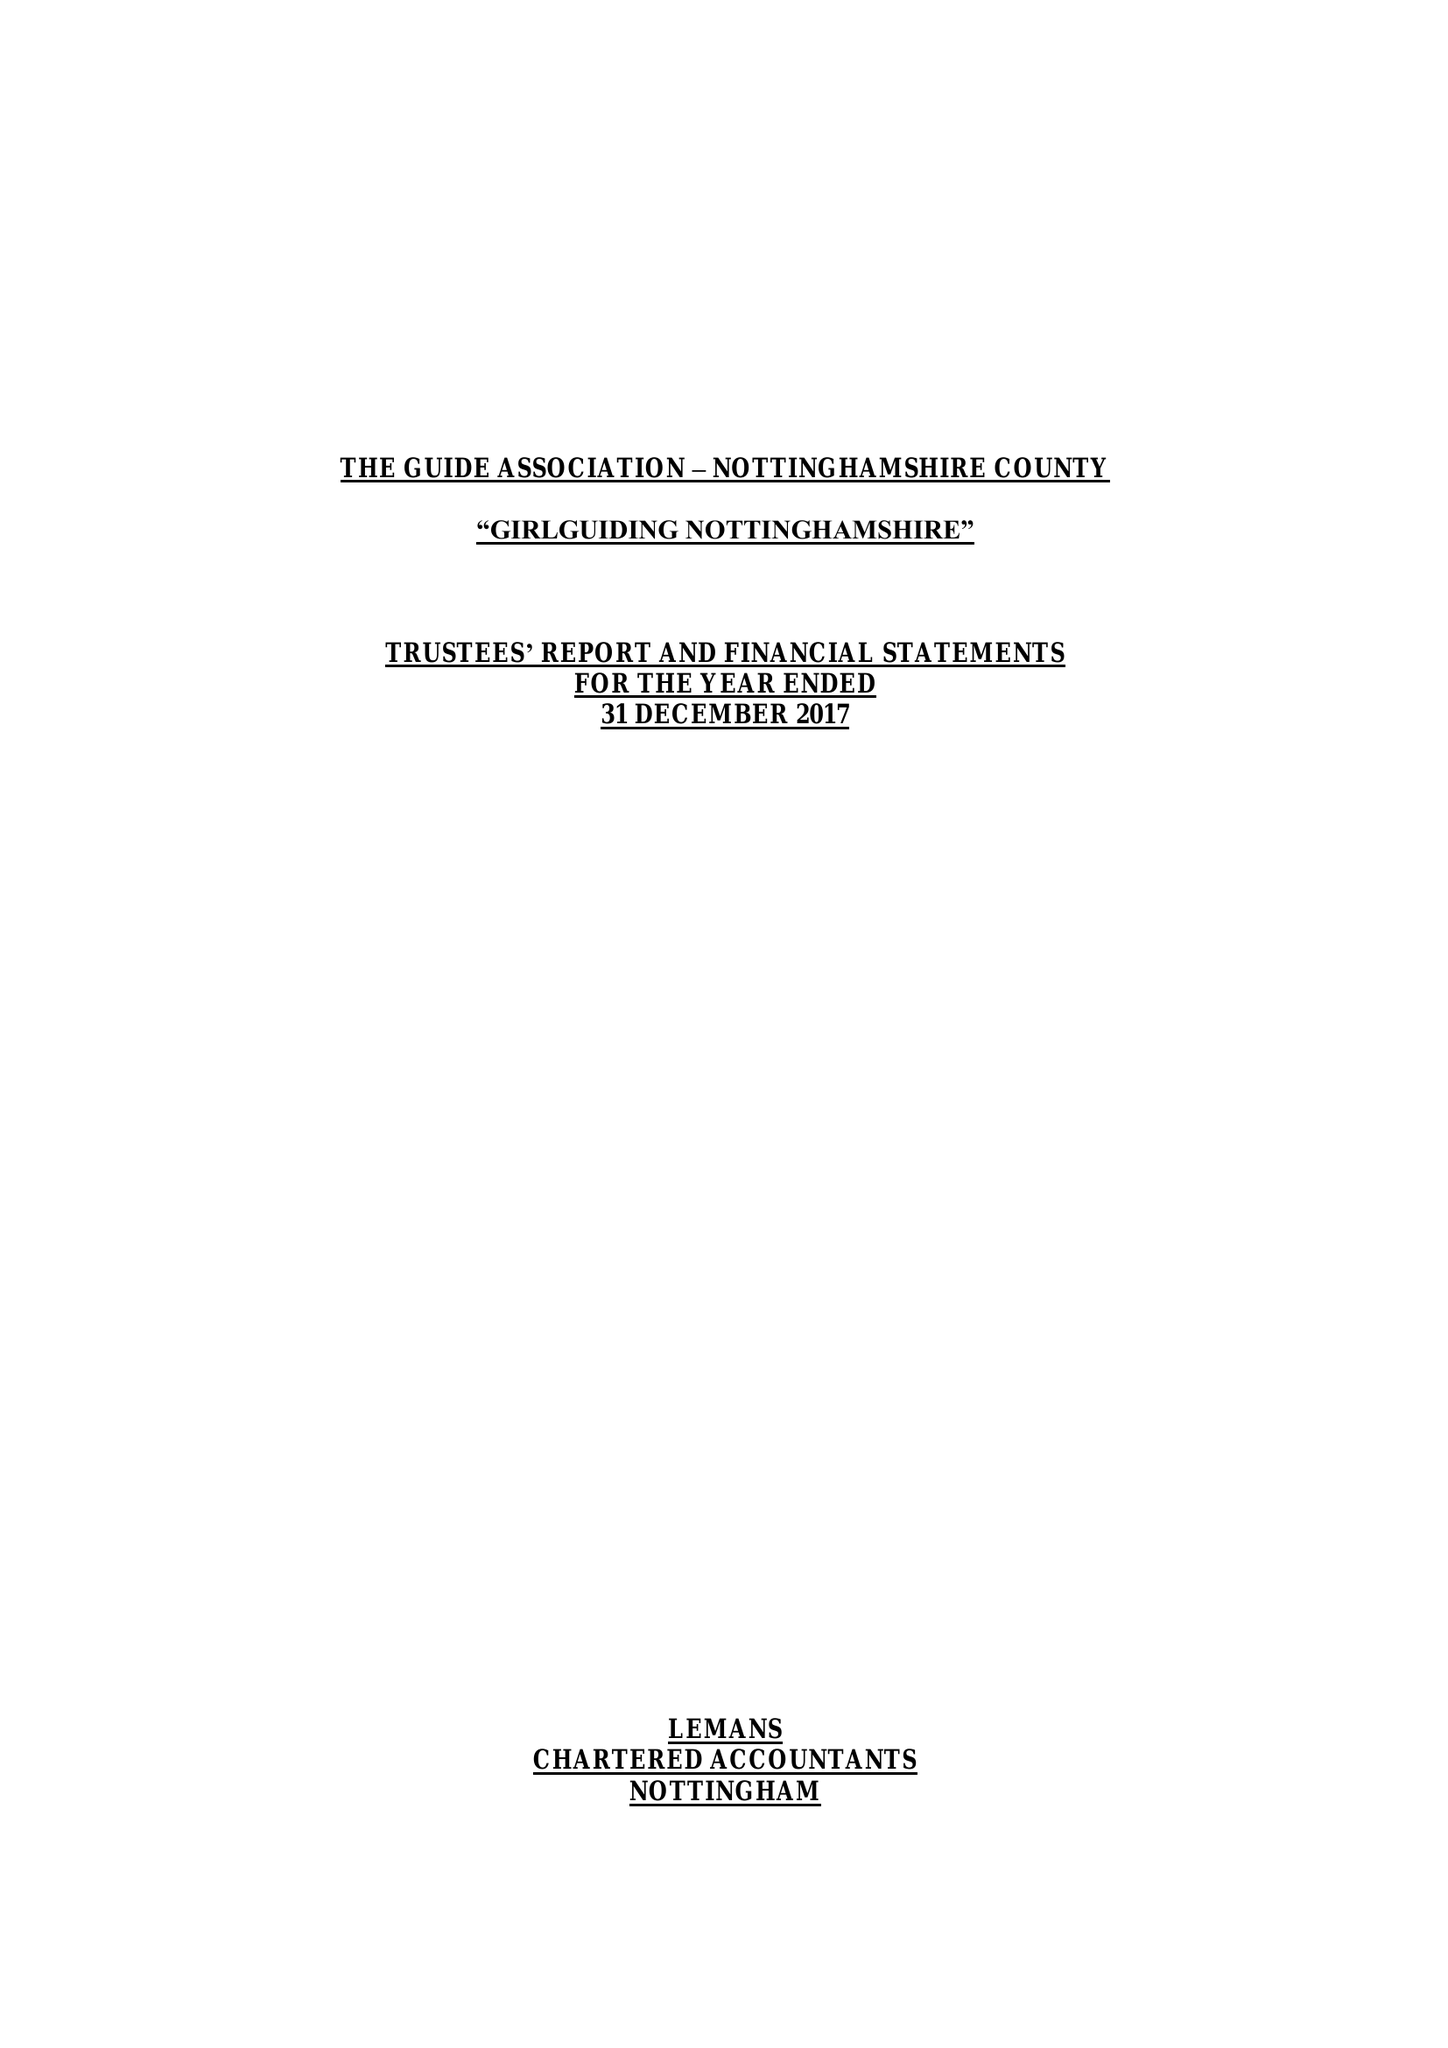What is the value for the address__post_town?
Answer the question using a single word or phrase. NOTTINGHAM 